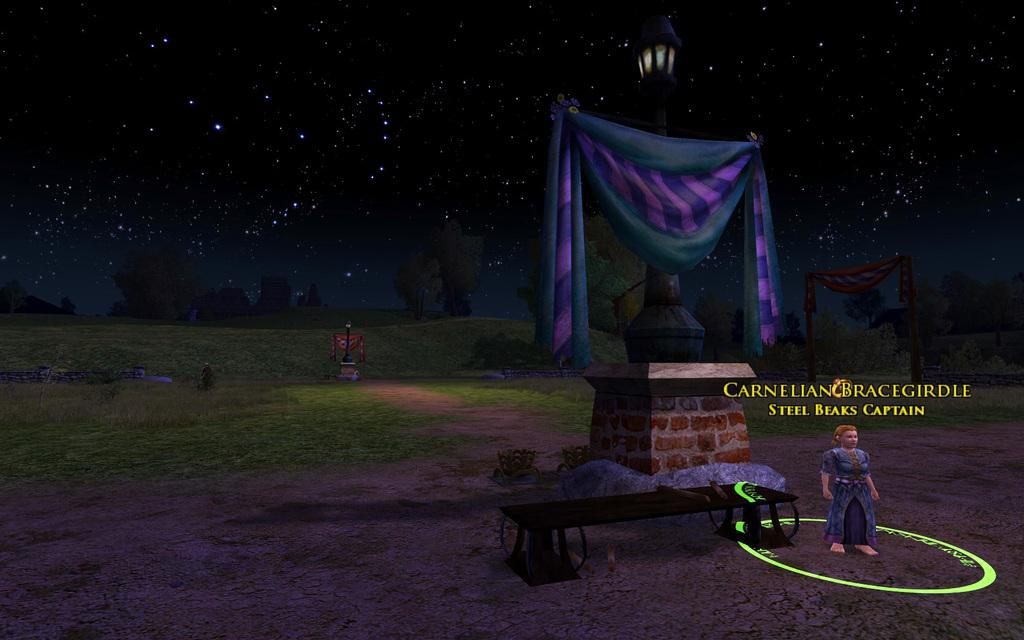What type of image is in the picture? There is a graphical image in the picture. Can you describe the person depicted in the image? There is a depiction of a person in the image. What type of natural environment is shown in the image? There is grass and trees depicted in the image. What architectural feature is present in the image? There is a pillar depicted in the image. What type of material is shown in the image? There is a cloth depicted in the image. What can be seen in the sky in the image? The sky is visible in the image. Is there any text present in the image? Yes, there is some text present in the image. What type of music is being played by the government in the image? There is no mention of music or government in the image; it features a graphical image with various elements. 